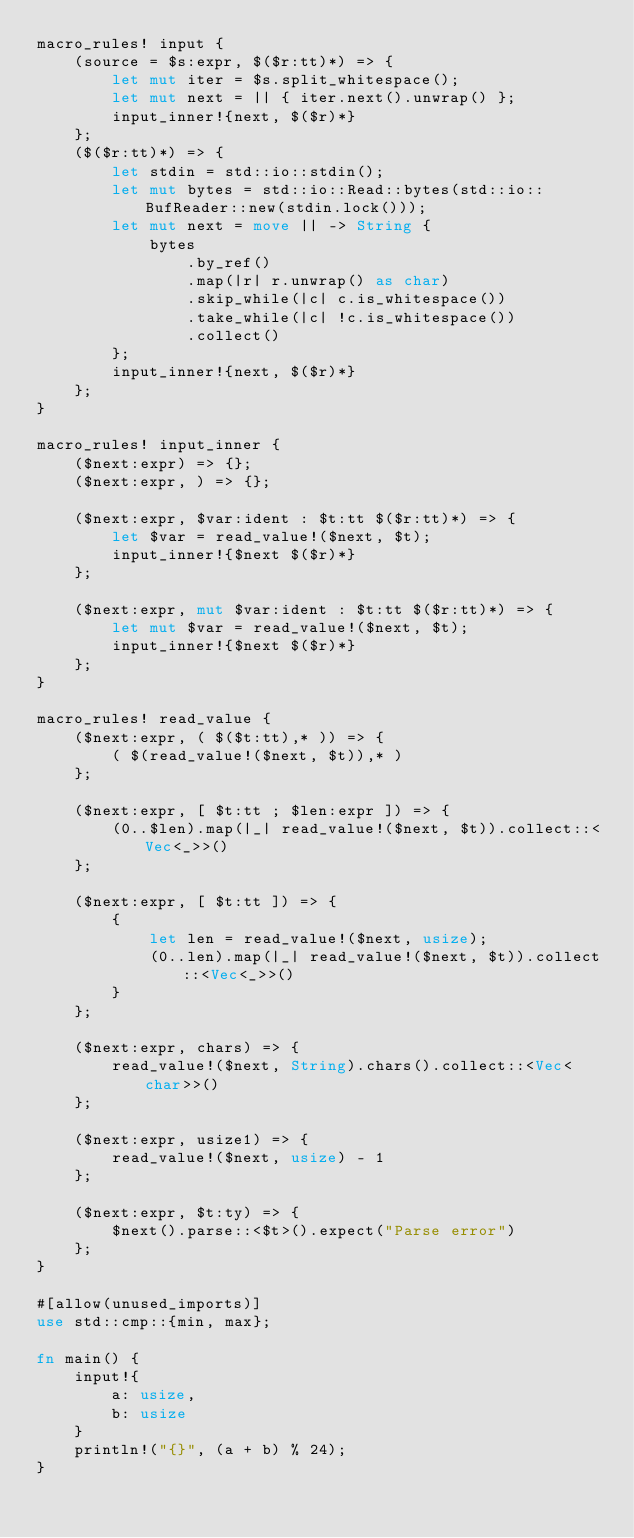<code> <loc_0><loc_0><loc_500><loc_500><_Rust_>macro_rules! input {
    (source = $s:expr, $($r:tt)*) => {
        let mut iter = $s.split_whitespace();
        let mut next = || { iter.next().unwrap() };
        input_inner!{next, $($r)*}
    };
    ($($r:tt)*) => {
        let stdin = std::io::stdin();
        let mut bytes = std::io::Read::bytes(std::io::BufReader::new(stdin.lock()));
        let mut next = move || -> String {
            bytes
                .by_ref()
                .map(|r| r.unwrap() as char)
                .skip_while(|c| c.is_whitespace())
                .take_while(|c| !c.is_whitespace())
                .collect()
        };
        input_inner!{next, $($r)*}
    };
}

macro_rules! input_inner {
    ($next:expr) => {};
    ($next:expr, ) => {};

    ($next:expr, $var:ident : $t:tt $($r:tt)*) => {
        let $var = read_value!($next, $t);
        input_inner!{$next $($r)*}
    };

    ($next:expr, mut $var:ident : $t:tt $($r:tt)*) => {
        let mut $var = read_value!($next, $t);
        input_inner!{$next $($r)*}
    };
}

macro_rules! read_value {
    ($next:expr, ( $($t:tt),* )) => {
        ( $(read_value!($next, $t)),* )
    };

    ($next:expr, [ $t:tt ; $len:expr ]) => {
        (0..$len).map(|_| read_value!($next, $t)).collect::<Vec<_>>()
    };

    ($next:expr, [ $t:tt ]) => {
        {
            let len = read_value!($next, usize);
            (0..len).map(|_| read_value!($next, $t)).collect::<Vec<_>>()
        }
    };

    ($next:expr, chars) => {
        read_value!($next, String).chars().collect::<Vec<char>>()
    };

    ($next:expr, usize1) => {
        read_value!($next, usize) - 1
    };

    ($next:expr, $t:ty) => {
        $next().parse::<$t>().expect("Parse error")
    };
}

#[allow(unused_imports)]
use std::cmp::{min, max};

fn main() {
    input!{
        a: usize,
        b: usize
    }
    println!("{}", (a + b) % 24);
}
</code> 